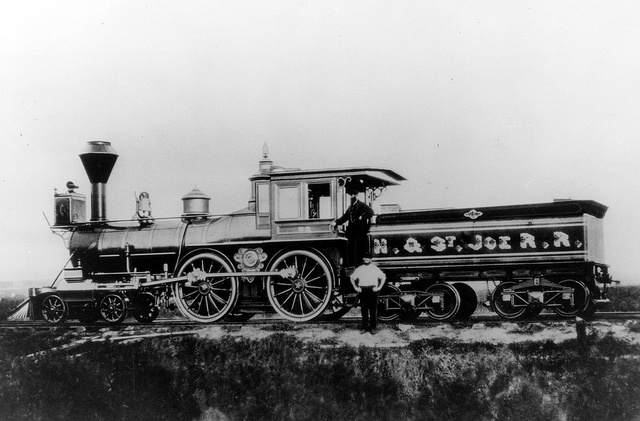Describe the objects in this image and their specific colors. I can see train in white, black, darkgray, gray, and lightgray tones, people in darkgray, black, gray, and white tones, and people in white, black, gray, darkgray, and lightgray tones in this image. 